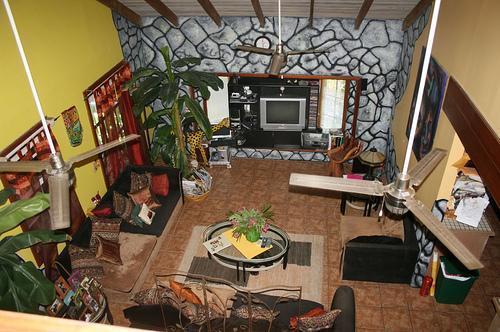How many potted plants are in the photo?
Give a very brief answer. 2. How many couches are in the picture?
Give a very brief answer. 2. How many people are there?
Give a very brief answer. 0. 